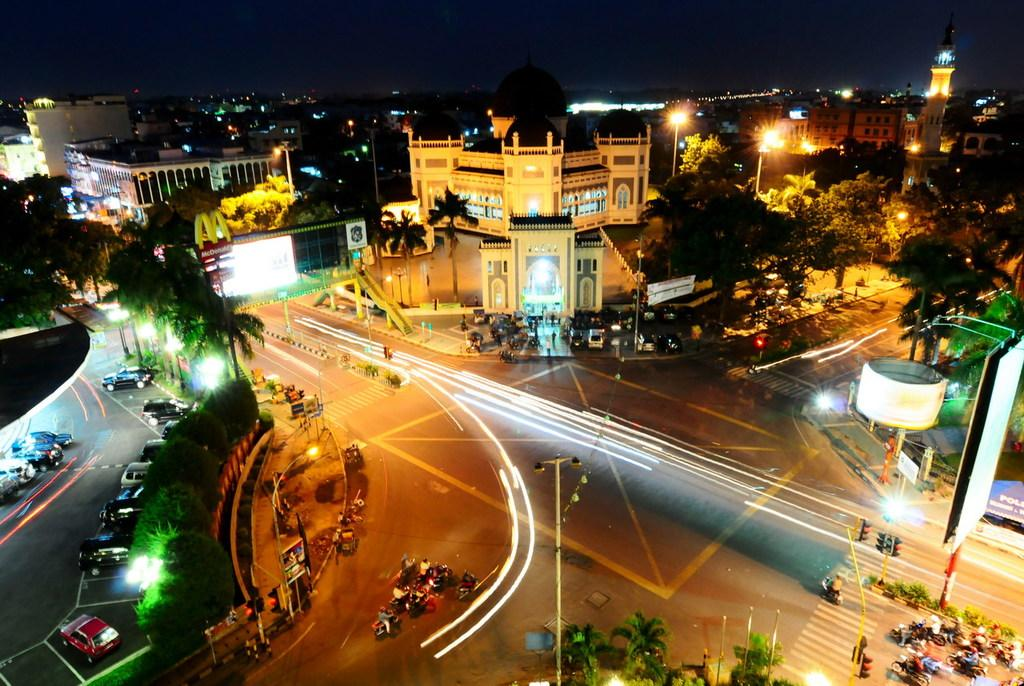What type of structures can be seen in the image? There are buildings and towers in the image. What can be observed in the image that provides illumination? There are lights in the image. What are the vertical structures in the image used for? There are poles in the image, which are likely used for supporting lights or other infrastructure. What is happening on the road in the image? There are vehicles on the road in the image. What type of signs are present in the image? There are name boards and signboards in the image. What objects are used to manage traffic in the image? There are traffic cones and traffic lights in the image. What type of feeling is expressed by the men in the image? There are no men present in the image, so it is not possible to determine any feelings expressed. What type of writing can be seen on the signboards in the image? There is no writing visible on the signboards in the image; only the signboards themselves are present. 